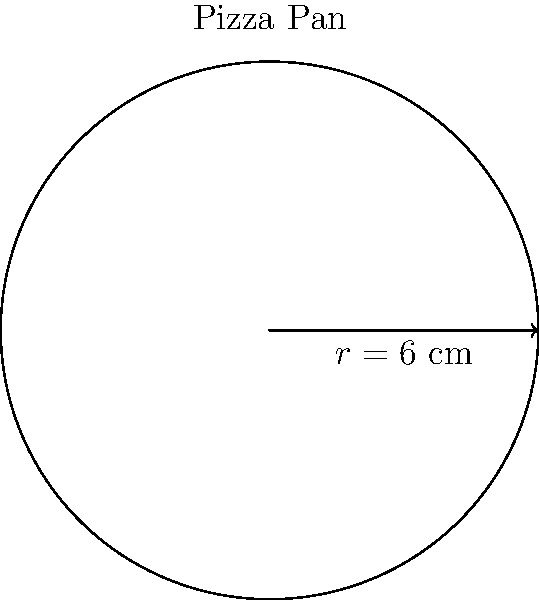As a Pizza Hut enthusiast, you're curious about the size of their signature pan pizzas. If the circular pizza pan has a radius of 6 cm, calculate its area using polar integration. Express your answer in terms of $\pi$ square centimeters. To find the area of the circular pizza pan using polar integration, we'll follow these steps:

1) The general formula for the area of a region in polar coordinates is:

   $$A = \int_{0}^{2\pi} \int_{0}^{r} \rho \, d\rho \, d\theta$$

2) In this case, $r$ is constant (6 cm), so our integral becomes:

   $$A = \int_{0}^{2\pi} \int_{0}^{6} \rho \, d\rho \, d\theta$$

3) Let's solve the inner integral first:

   $$\int_{0}^{6} \rho \, d\rho = \frac{1}{2}\rho^2 \bigg|_{0}^{6} = \frac{1}{2}(6^2 - 0^2) = 18$$

4) Now our integral is:

   $$A = \int_{0}^{2\pi} 18 \, d\theta$$

5) Solving this:

   $$A = 18\theta \bigg|_{0}^{2\pi} = 18(2\pi - 0) = 36\pi$$

Therefore, the area of the pizza pan is $36\pi$ square centimeters.
Answer: $36\pi$ cm² 